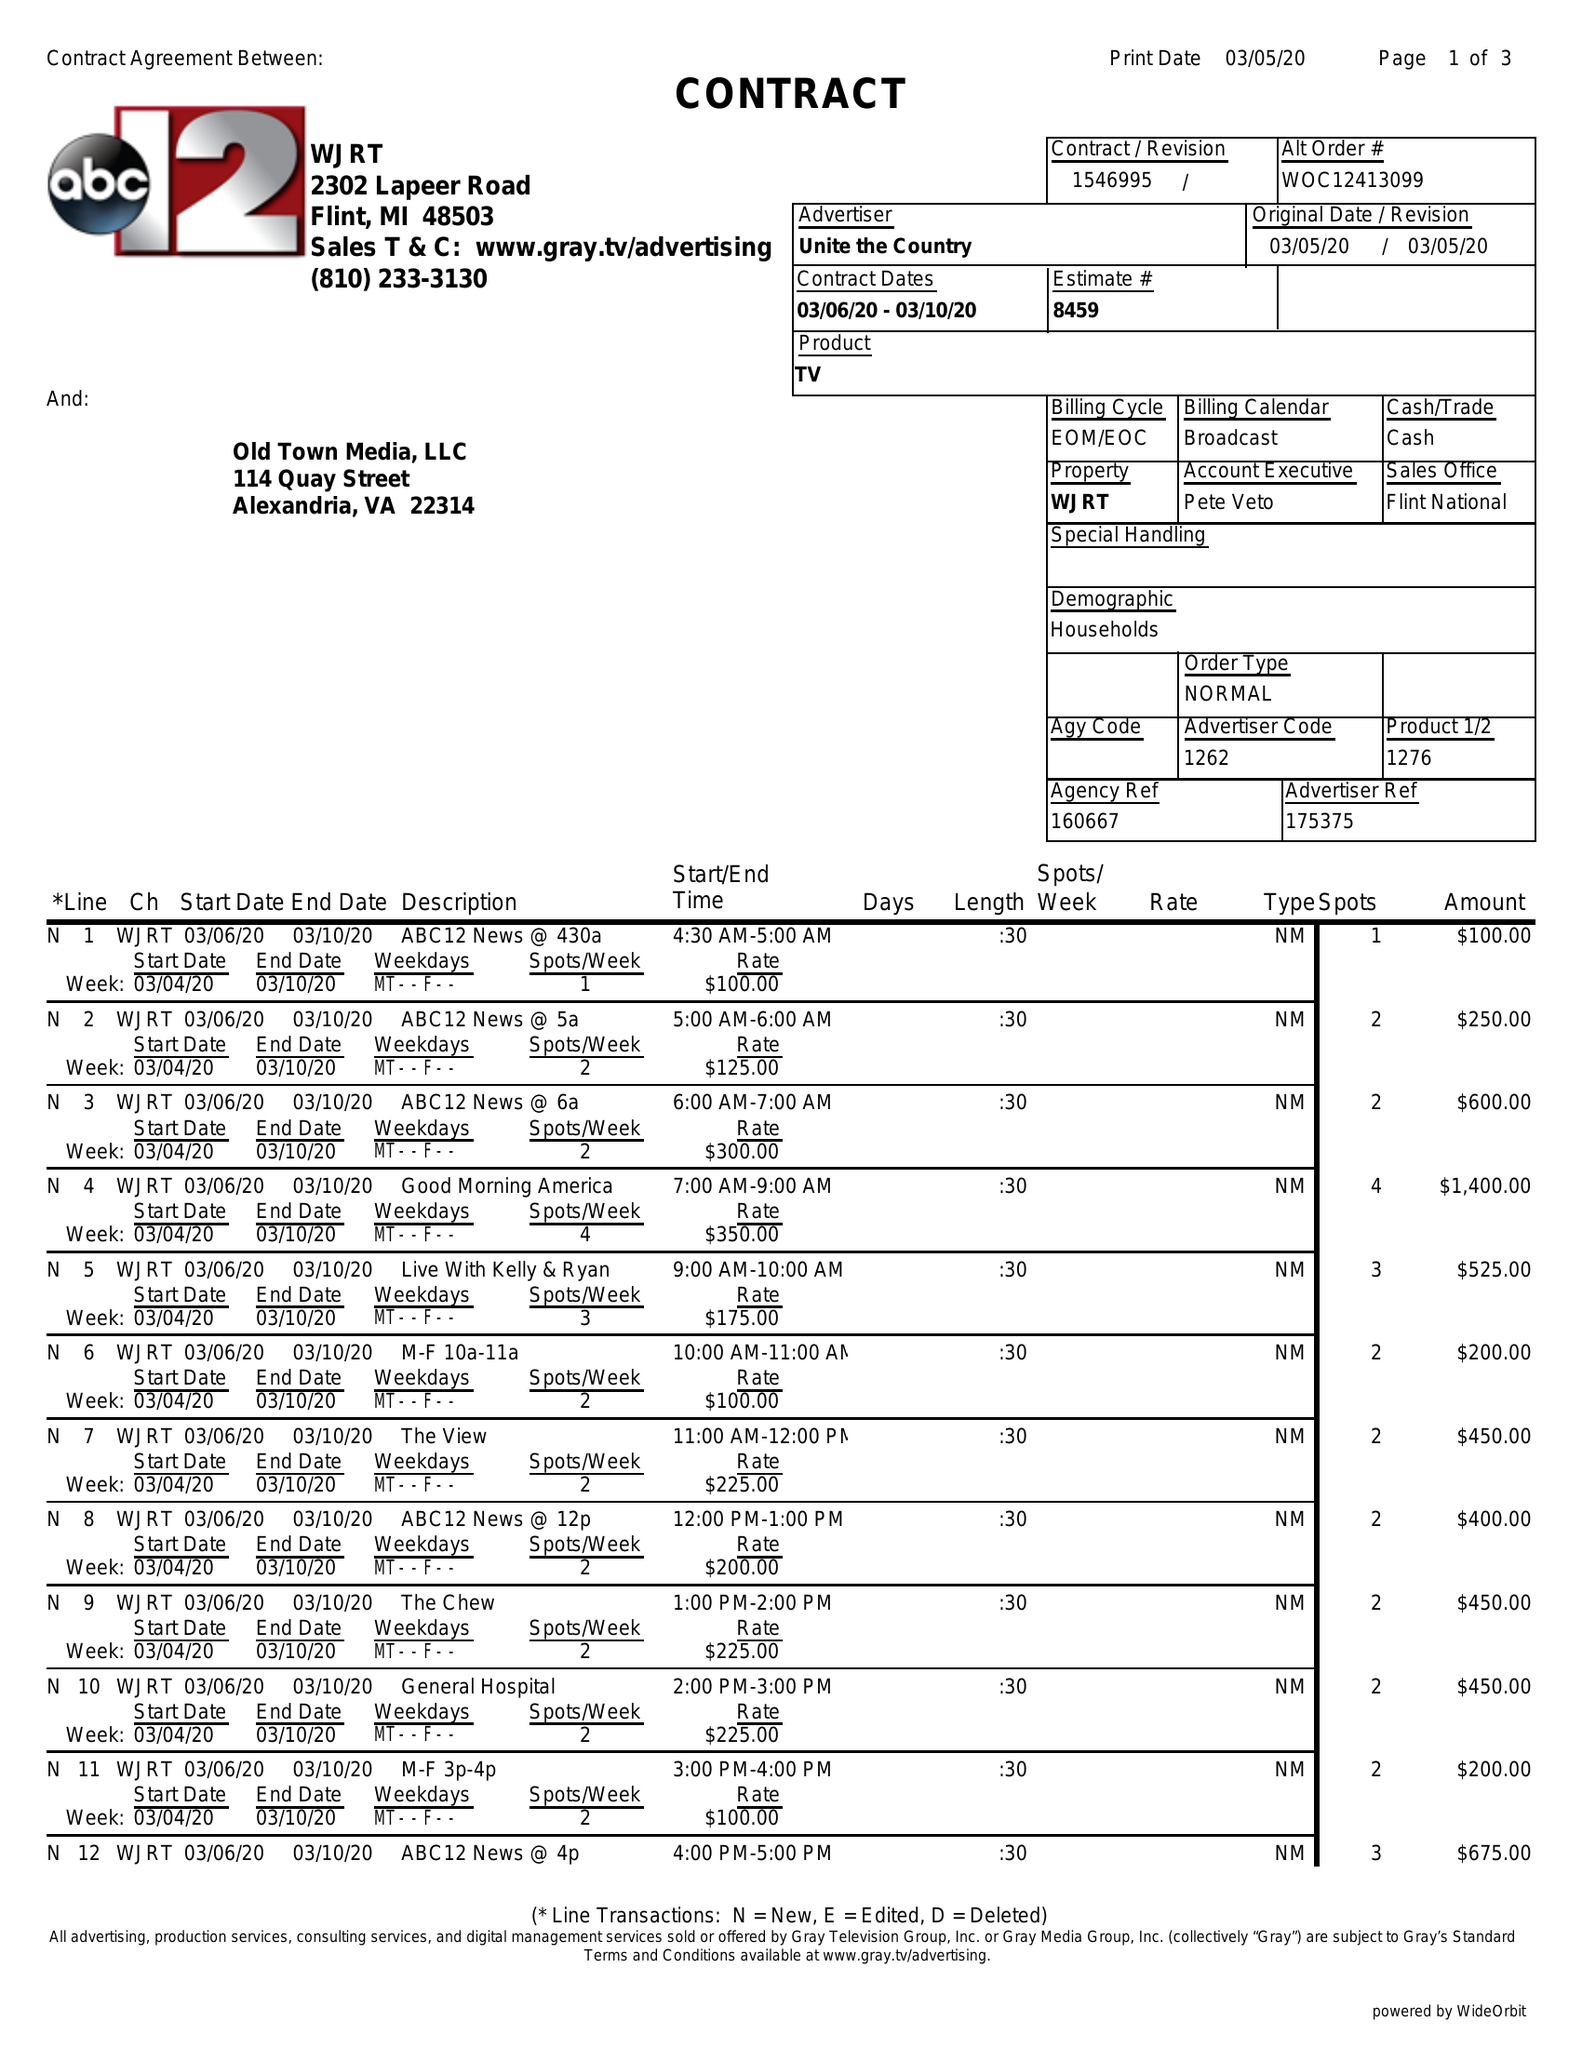What is the value for the gross_amount?
Answer the question using a single word or phrase. 23200.00 